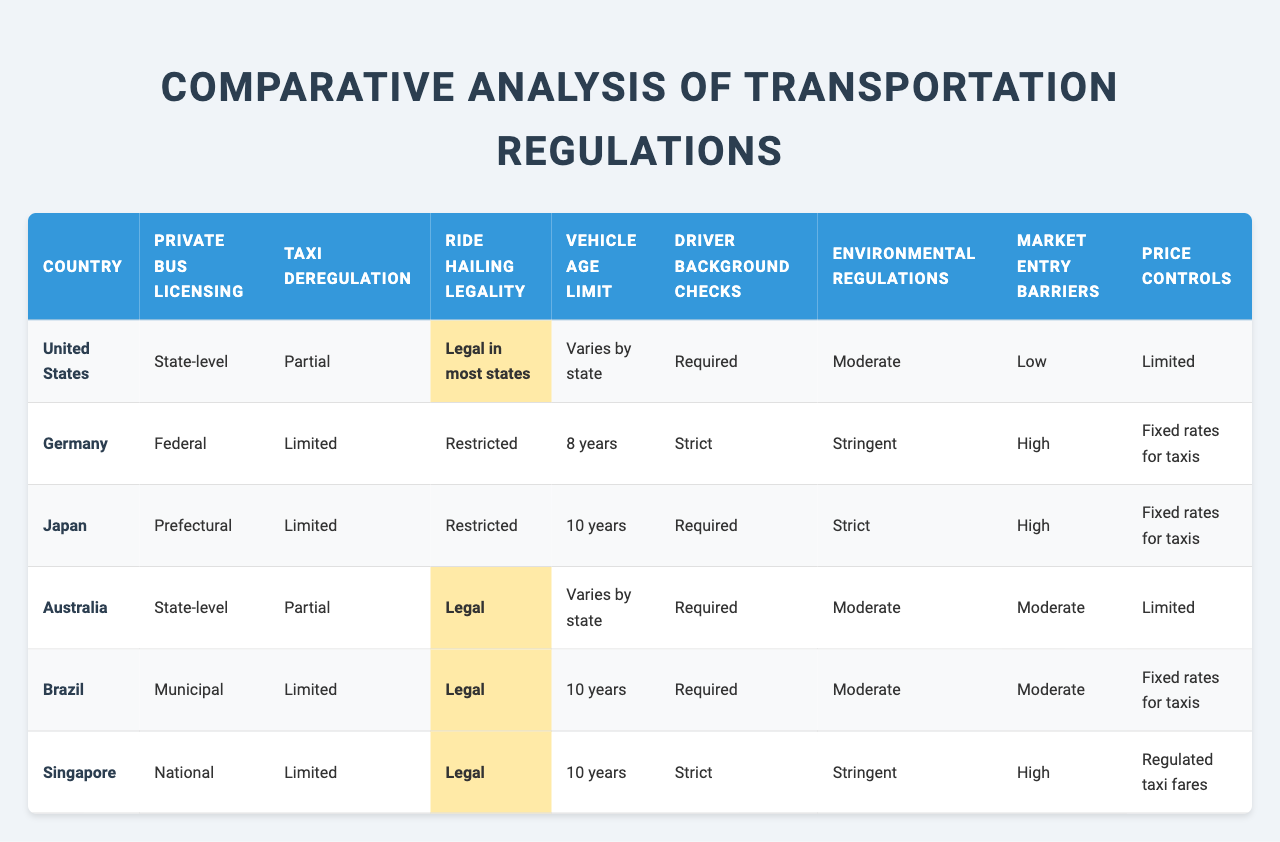What is the private bus licensing system in the United States? According to the table, the private bus licensing system in the United States is at the state level.
Answer: State-level How many countries have ride-hailing classified as legal? The table lists five countries, and the ride-hailing legality is marked as legal for the United States, Australia, Brazil, and Singapore, totaling four countries.
Answer: 4 Does Germany have strict driver background checks? Yes, the table indicates that Germany has strict driver background checks.
Answer: Yes Which country has the lowest market entry barriers? The United States is identified in the table as having low market entry barriers compared to the other listed countries.
Answer: United States Which country has the highest vehicle age limit for taxis? The table shows that Japan has the highest vehicle age limit at 10 years, but it's tied with Brazil and Singapore, so multiple entries are valid.
Answer: Japan, Brazil, Singapore Is ride-hailing legal in Germany? The table states that ride-hailing legality in Germany is restricted, which means it is not fully legal.
Answer: No How do environmental regulations in Singapore compare to those in the United States? In Singapore, environmental regulations are stringent, while in the United States they are classified as moderate, indicating that Singapore has tougher requirements than the U.S.
Answer: Singapore has stricter regulations What is the average vehicle age limit across the countries listed? The vehicle age limits are as follows: United States (Varies), Germany (8 years), Japan (10 years), Australia (Varies), Brazil (10 years), Singapore (10 years). Excluding "Varies," the average of 8, 10, 10, and 10 equals 9.5 years. Therefore, considering non-variable limits, the average is approximately 9.5 years.
Answer: 9.5 years How do taxi deregulation levels vary among the countries? The table lists the taxi deregulation levels as: United States (Partial), Germany (Limited), Japan (Limited), Australia (Partial), Brazil (Limited), Singapore (Limited). The variations indicate that the U.S. and Australia have partial deregulation, while the others are more limited.
Answer: Varies; U.S. and Australia have partial, others limited What is the relationship between market entry barriers and taxi deregulation in Germany? The table shows that Germany has high market entry barriers and limited taxi deregulation, suggesting that stricter regulations may contribute to higher barriers for new entrants into the taxi market.
Answer: Stricter regulations lead to higher barriers 